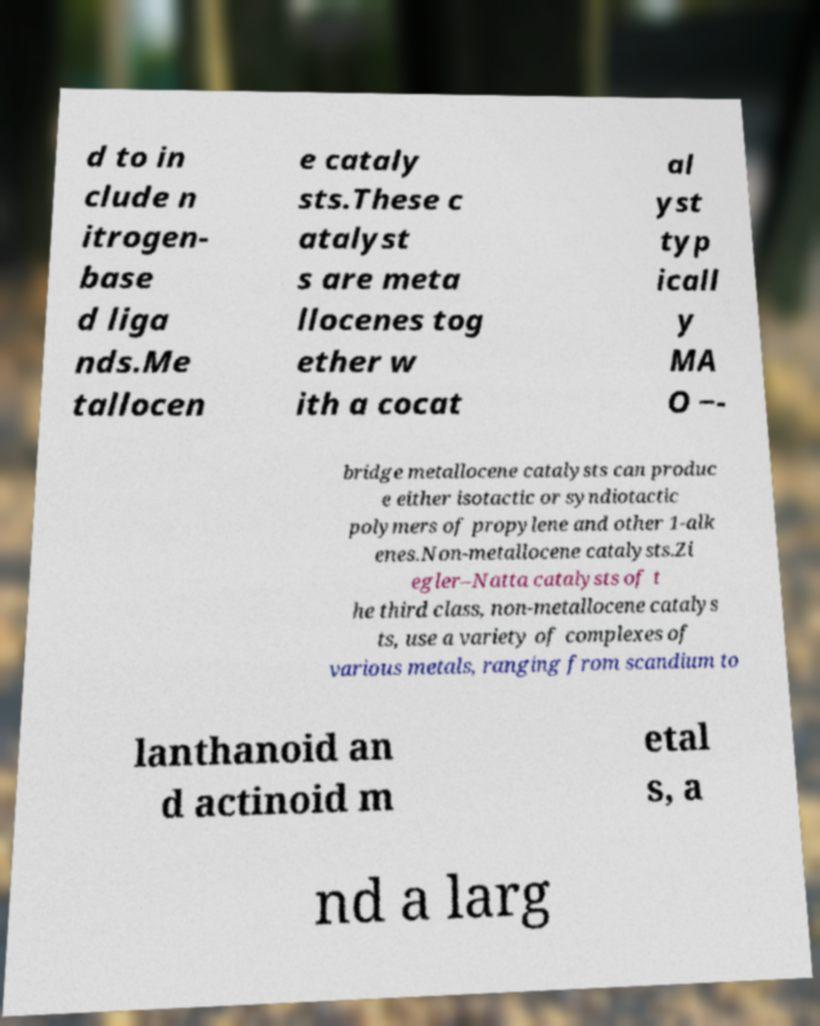Could you extract and type out the text from this image? d to in clude n itrogen- base d liga nds.Me tallocen e cataly sts.These c atalyst s are meta llocenes tog ether w ith a cocat al yst typ icall y MA O −- bridge metallocene catalysts can produc e either isotactic or syndiotactic polymers of propylene and other 1-alk enes.Non-metallocene catalysts.Zi egler–Natta catalysts of t he third class, non-metallocene catalys ts, use a variety of complexes of various metals, ranging from scandium to lanthanoid an d actinoid m etal s, a nd a larg 